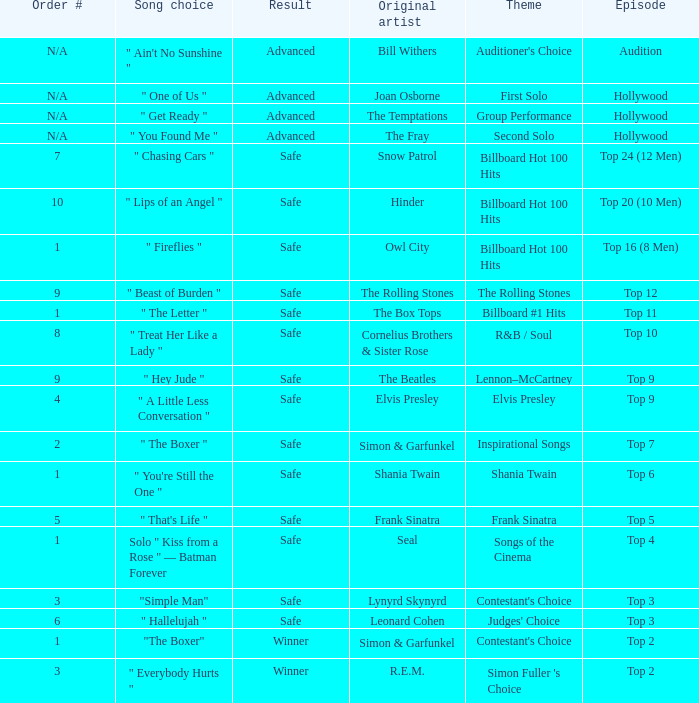The song choice " One of Us " has what themes? First Solo. 